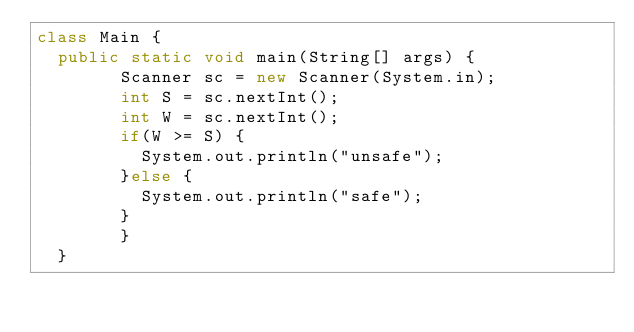<code> <loc_0><loc_0><loc_500><loc_500><_Java_>class Main {
	public static void main(String[] args) {
        Scanner sc = new Scanner(System.in);
        int S = sc.nextInt();
        int W = sc.nextInt();
        if(W >= S) {
        	System.out.println("unsafe");
        }else {
        	System.out.println("safe");
        }
        }
	}
</code> 